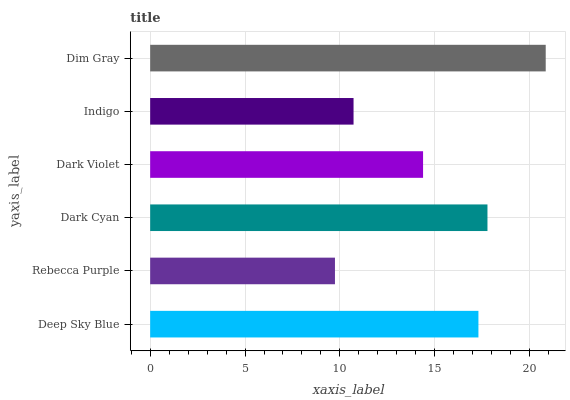Is Rebecca Purple the minimum?
Answer yes or no. Yes. Is Dim Gray the maximum?
Answer yes or no. Yes. Is Dark Cyan the minimum?
Answer yes or no. No. Is Dark Cyan the maximum?
Answer yes or no. No. Is Dark Cyan greater than Rebecca Purple?
Answer yes or no. Yes. Is Rebecca Purple less than Dark Cyan?
Answer yes or no. Yes. Is Rebecca Purple greater than Dark Cyan?
Answer yes or no. No. Is Dark Cyan less than Rebecca Purple?
Answer yes or no. No. Is Deep Sky Blue the high median?
Answer yes or no. Yes. Is Dark Violet the low median?
Answer yes or no. Yes. Is Dark Cyan the high median?
Answer yes or no. No. Is Indigo the low median?
Answer yes or no. No. 